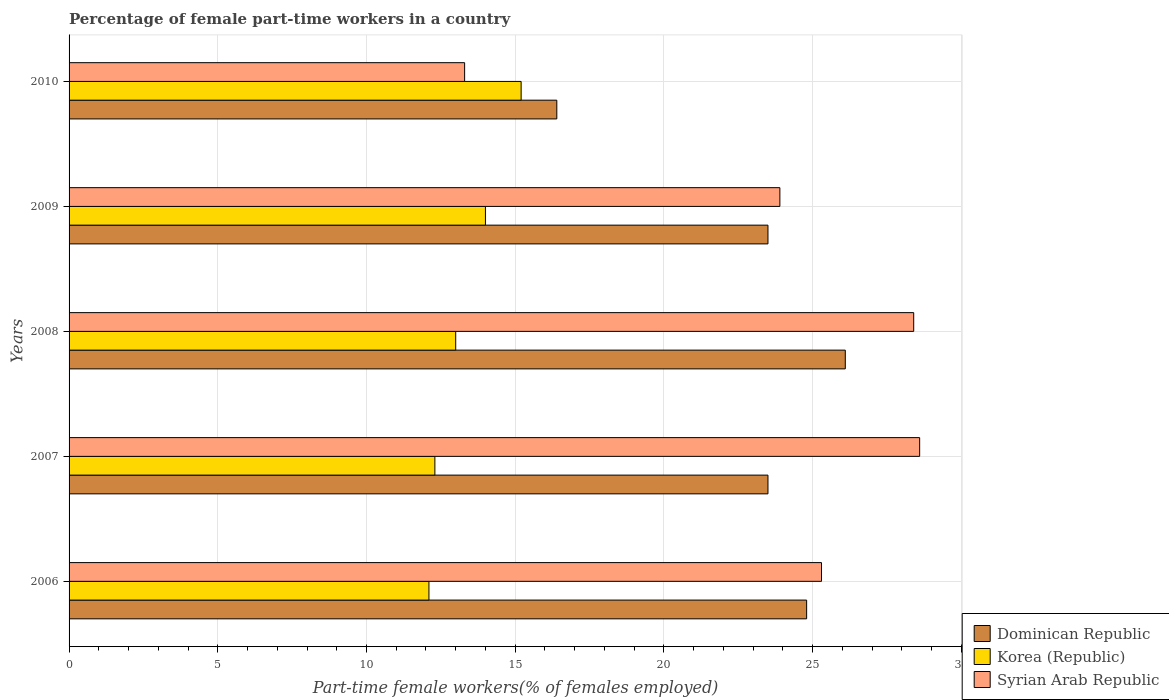How many groups of bars are there?
Your answer should be compact. 5. How many bars are there on the 1st tick from the top?
Offer a very short reply. 3. In how many cases, is the number of bars for a given year not equal to the number of legend labels?
Keep it short and to the point. 0. What is the percentage of female part-time workers in Korea (Republic) in 2007?
Make the answer very short. 12.3. Across all years, what is the maximum percentage of female part-time workers in Syrian Arab Republic?
Offer a very short reply. 28.6. Across all years, what is the minimum percentage of female part-time workers in Syrian Arab Republic?
Your answer should be compact. 13.3. In which year was the percentage of female part-time workers in Dominican Republic maximum?
Provide a succinct answer. 2008. What is the total percentage of female part-time workers in Dominican Republic in the graph?
Keep it short and to the point. 114.3. What is the difference between the percentage of female part-time workers in Syrian Arab Republic in 2007 and that in 2009?
Offer a terse response. 4.7. What is the difference between the percentage of female part-time workers in Dominican Republic in 2009 and the percentage of female part-time workers in Syrian Arab Republic in 2008?
Your answer should be compact. -4.9. What is the average percentage of female part-time workers in Korea (Republic) per year?
Offer a terse response. 13.32. In the year 2006, what is the difference between the percentage of female part-time workers in Syrian Arab Republic and percentage of female part-time workers in Korea (Republic)?
Give a very brief answer. 13.2. What is the ratio of the percentage of female part-time workers in Korea (Republic) in 2007 to that in 2009?
Your response must be concise. 0.88. Is the percentage of female part-time workers in Syrian Arab Republic in 2006 less than that in 2010?
Provide a short and direct response. No. What is the difference between the highest and the second highest percentage of female part-time workers in Syrian Arab Republic?
Keep it short and to the point. 0.2. What is the difference between the highest and the lowest percentage of female part-time workers in Korea (Republic)?
Make the answer very short. 3.1. What does the 3rd bar from the top in 2006 represents?
Ensure brevity in your answer.  Dominican Republic. What does the 2nd bar from the bottom in 2009 represents?
Keep it short and to the point. Korea (Republic). Is it the case that in every year, the sum of the percentage of female part-time workers in Korea (Republic) and percentage of female part-time workers in Syrian Arab Republic is greater than the percentage of female part-time workers in Dominican Republic?
Provide a short and direct response. Yes. How many bars are there?
Your response must be concise. 15. Are all the bars in the graph horizontal?
Your answer should be compact. Yes. What is the difference between two consecutive major ticks on the X-axis?
Give a very brief answer. 5. Are the values on the major ticks of X-axis written in scientific E-notation?
Keep it short and to the point. No. Does the graph contain any zero values?
Give a very brief answer. No. Where does the legend appear in the graph?
Your answer should be very brief. Bottom right. What is the title of the graph?
Offer a terse response. Percentage of female part-time workers in a country. What is the label or title of the X-axis?
Make the answer very short. Part-time female workers(% of females employed). What is the label or title of the Y-axis?
Your response must be concise. Years. What is the Part-time female workers(% of females employed) of Dominican Republic in 2006?
Provide a succinct answer. 24.8. What is the Part-time female workers(% of females employed) in Korea (Republic) in 2006?
Your answer should be very brief. 12.1. What is the Part-time female workers(% of females employed) of Syrian Arab Republic in 2006?
Offer a very short reply. 25.3. What is the Part-time female workers(% of females employed) of Korea (Republic) in 2007?
Your answer should be very brief. 12.3. What is the Part-time female workers(% of females employed) of Syrian Arab Republic in 2007?
Make the answer very short. 28.6. What is the Part-time female workers(% of females employed) of Dominican Republic in 2008?
Offer a terse response. 26.1. What is the Part-time female workers(% of females employed) in Korea (Republic) in 2008?
Your answer should be very brief. 13. What is the Part-time female workers(% of females employed) in Syrian Arab Republic in 2008?
Give a very brief answer. 28.4. What is the Part-time female workers(% of females employed) in Dominican Republic in 2009?
Your answer should be very brief. 23.5. What is the Part-time female workers(% of females employed) of Syrian Arab Republic in 2009?
Your answer should be compact. 23.9. What is the Part-time female workers(% of females employed) of Dominican Republic in 2010?
Your response must be concise. 16.4. What is the Part-time female workers(% of females employed) in Korea (Republic) in 2010?
Provide a short and direct response. 15.2. What is the Part-time female workers(% of females employed) in Syrian Arab Republic in 2010?
Your answer should be very brief. 13.3. Across all years, what is the maximum Part-time female workers(% of females employed) in Dominican Republic?
Provide a short and direct response. 26.1. Across all years, what is the maximum Part-time female workers(% of females employed) in Korea (Republic)?
Offer a terse response. 15.2. Across all years, what is the maximum Part-time female workers(% of females employed) of Syrian Arab Republic?
Keep it short and to the point. 28.6. Across all years, what is the minimum Part-time female workers(% of females employed) in Dominican Republic?
Your response must be concise. 16.4. Across all years, what is the minimum Part-time female workers(% of females employed) of Korea (Republic)?
Provide a succinct answer. 12.1. Across all years, what is the minimum Part-time female workers(% of females employed) in Syrian Arab Republic?
Offer a very short reply. 13.3. What is the total Part-time female workers(% of females employed) in Dominican Republic in the graph?
Ensure brevity in your answer.  114.3. What is the total Part-time female workers(% of females employed) of Korea (Republic) in the graph?
Offer a terse response. 66.6. What is the total Part-time female workers(% of females employed) of Syrian Arab Republic in the graph?
Your answer should be very brief. 119.5. What is the difference between the Part-time female workers(% of females employed) in Dominican Republic in 2006 and that in 2007?
Your answer should be very brief. 1.3. What is the difference between the Part-time female workers(% of females employed) of Korea (Republic) in 2006 and that in 2007?
Your answer should be compact. -0.2. What is the difference between the Part-time female workers(% of females employed) of Syrian Arab Republic in 2006 and that in 2007?
Provide a succinct answer. -3.3. What is the difference between the Part-time female workers(% of females employed) of Korea (Republic) in 2006 and that in 2008?
Give a very brief answer. -0.9. What is the difference between the Part-time female workers(% of females employed) in Korea (Republic) in 2006 and that in 2009?
Ensure brevity in your answer.  -1.9. What is the difference between the Part-time female workers(% of females employed) of Syrian Arab Republic in 2006 and that in 2009?
Your answer should be very brief. 1.4. What is the difference between the Part-time female workers(% of females employed) of Dominican Republic in 2007 and that in 2008?
Your response must be concise. -2.6. What is the difference between the Part-time female workers(% of females employed) in Korea (Republic) in 2007 and that in 2008?
Provide a succinct answer. -0.7. What is the difference between the Part-time female workers(% of females employed) of Korea (Republic) in 2007 and that in 2009?
Keep it short and to the point. -1.7. What is the difference between the Part-time female workers(% of females employed) of Syrian Arab Republic in 2007 and that in 2009?
Provide a succinct answer. 4.7. What is the difference between the Part-time female workers(% of females employed) of Dominican Republic in 2007 and that in 2010?
Offer a very short reply. 7.1. What is the difference between the Part-time female workers(% of females employed) in Korea (Republic) in 2007 and that in 2010?
Provide a short and direct response. -2.9. What is the difference between the Part-time female workers(% of females employed) of Dominican Republic in 2008 and that in 2009?
Provide a succinct answer. 2.6. What is the difference between the Part-time female workers(% of females employed) in Dominican Republic in 2009 and that in 2010?
Provide a short and direct response. 7.1. What is the difference between the Part-time female workers(% of females employed) in Syrian Arab Republic in 2009 and that in 2010?
Ensure brevity in your answer.  10.6. What is the difference between the Part-time female workers(% of females employed) of Korea (Republic) in 2006 and the Part-time female workers(% of females employed) of Syrian Arab Republic in 2007?
Your response must be concise. -16.5. What is the difference between the Part-time female workers(% of females employed) of Dominican Republic in 2006 and the Part-time female workers(% of females employed) of Korea (Republic) in 2008?
Offer a terse response. 11.8. What is the difference between the Part-time female workers(% of females employed) of Korea (Republic) in 2006 and the Part-time female workers(% of females employed) of Syrian Arab Republic in 2008?
Ensure brevity in your answer.  -16.3. What is the difference between the Part-time female workers(% of females employed) in Korea (Republic) in 2006 and the Part-time female workers(% of females employed) in Syrian Arab Republic in 2010?
Provide a succinct answer. -1.2. What is the difference between the Part-time female workers(% of females employed) in Dominican Republic in 2007 and the Part-time female workers(% of females employed) in Korea (Republic) in 2008?
Offer a terse response. 10.5. What is the difference between the Part-time female workers(% of females employed) of Korea (Republic) in 2007 and the Part-time female workers(% of females employed) of Syrian Arab Republic in 2008?
Your response must be concise. -16.1. What is the difference between the Part-time female workers(% of females employed) of Dominican Republic in 2007 and the Part-time female workers(% of females employed) of Syrian Arab Republic in 2009?
Provide a short and direct response. -0.4. What is the difference between the Part-time female workers(% of females employed) in Korea (Republic) in 2007 and the Part-time female workers(% of females employed) in Syrian Arab Republic in 2009?
Make the answer very short. -11.6. What is the difference between the Part-time female workers(% of females employed) in Dominican Republic in 2007 and the Part-time female workers(% of females employed) in Korea (Republic) in 2010?
Your answer should be compact. 8.3. What is the difference between the Part-time female workers(% of females employed) of Dominican Republic in 2007 and the Part-time female workers(% of females employed) of Syrian Arab Republic in 2010?
Make the answer very short. 10.2. What is the difference between the Part-time female workers(% of females employed) in Dominican Republic in 2008 and the Part-time female workers(% of females employed) in Syrian Arab Republic in 2009?
Ensure brevity in your answer.  2.2. What is the difference between the Part-time female workers(% of females employed) of Korea (Republic) in 2008 and the Part-time female workers(% of females employed) of Syrian Arab Republic in 2010?
Offer a very short reply. -0.3. What is the difference between the Part-time female workers(% of females employed) of Dominican Republic in 2009 and the Part-time female workers(% of females employed) of Korea (Republic) in 2010?
Offer a very short reply. 8.3. What is the difference between the Part-time female workers(% of females employed) of Dominican Republic in 2009 and the Part-time female workers(% of females employed) of Syrian Arab Republic in 2010?
Offer a terse response. 10.2. What is the average Part-time female workers(% of females employed) of Dominican Republic per year?
Keep it short and to the point. 22.86. What is the average Part-time female workers(% of females employed) of Korea (Republic) per year?
Give a very brief answer. 13.32. What is the average Part-time female workers(% of females employed) in Syrian Arab Republic per year?
Make the answer very short. 23.9. In the year 2006, what is the difference between the Part-time female workers(% of females employed) in Dominican Republic and Part-time female workers(% of females employed) in Korea (Republic)?
Your response must be concise. 12.7. In the year 2007, what is the difference between the Part-time female workers(% of females employed) of Dominican Republic and Part-time female workers(% of females employed) of Korea (Republic)?
Your response must be concise. 11.2. In the year 2007, what is the difference between the Part-time female workers(% of females employed) of Korea (Republic) and Part-time female workers(% of females employed) of Syrian Arab Republic?
Your response must be concise. -16.3. In the year 2008, what is the difference between the Part-time female workers(% of females employed) in Dominican Republic and Part-time female workers(% of females employed) in Korea (Republic)?
Keep it short and to the point. 13.1. In the year 2008, what is the difference between the Part-time female workers(% of females employed) in Korea (Republic) and Part-time female workers(% of females employed) in Syrian Arab Republic?
Keep it short and to the point. -15.4. In the year 2009, what is the difference between the Part-time female workers(% of females employed) in Dominican Republic and Part-time female workers(% of females employed) in Korea (Republic)?
Your answer should be compact. 9.5. In the year 2010, what is the difference between the Part-time female workers(% of females employed) of Dominican Republic and Part-time female workers(% of females employed) of Korea (Republic)?
Make the answer very short. 1.2. In the year 2010, what is the difference between the Part-time female workers(% of females employed) in Dominican Republic and Part-time female workers(% of females employed) in Syrian Arab Republic?
Your answer should be compact. 3.1. In the year 2010, what is the difference between the Part-time female workers(% of females employed) in Korea (Republic) and Part-time female workers(% of females employed) in Syrian Arab Republic?
Give a very brief answer. 1.9. What is the ratio of the Part-time female workers(% of females employed) of Dominican Republic in 2006 to that in 2007?
Offer a very short reply. 1.06. What is the ratio of the Part-time female workers(% of females employed) in Korea (Republic) in 2006 to that in 2007?
Give a very brief answer. 0.98. What is the ratio of the Part-time female workers(% of females employed) of Syrian Arab Republic in 2006 to that in 2007?
Your answer should be very brief. 0.88. What is the ratio of the Part-time female workers(% of females employed) of Dominican Republic in 2006 to that in 2008?
Ensure brevity in your answer.  0.95. What is the ratio of the Part-time female workers(% of females employed) of Korea (Republic) in 2006 to that in 2008?
Your answer should be very brief. 0.93. What is the ratio of the Part-time female workers(% of females employed) of Syrian Arab Republic in 2006 to that in 2008?
Your answer should be compact. 0.89. What is the ratio of the Part-time female workers(% of females employed) in Dominican Republic in 2006 to that in 2009?
Offer a terse response. 1.06. What is the ratio of the Part-time female workers(% of females employed) of Korea (Republic) in 2006 to that in 2009?
Offer a terse response. 0.86. What is the ratio of the Part-time female workers(% of females employed) of Syrian Arab Republic in 2006 to that in 2009?
Provide a succinct answer. 1.06. What is the ratio of the Part-time female workers(% of females employed) in Dominican Republic in 2006 to that in 2010?
Ensure brevity in your answer.  1.51. What is the ratio of the Part-time female workers(% of females employed) of Korea (Republic) in 2006 to that in 2010?
Offer a very short reply. 0.8. What is the ratio of the Part-time female workers(% of females employed) of Syrian Arab Republic in 2006 to that in 2010?
Provide a succinct answer. 1.9. What is the ratio of the Part-time female workers(% of females employed) in Dominican Republic in 2007 to that in 2008?
Your response must be concise. 0.9. What is the ratio of the Part-time female workers(% of females employed) of Korea (Republic) in 2007 to that in 2008?
Your response must be concise. 0.95. What is the ratio of the Part-time female workers(% of females employed) of Dominican Republic in 2007 to that in 2009?
Your answer should be compact. 1. What is the ratio of the Part-time female workers(% of females employed) of Korea (Republic) in 2007 to that in 2009?
Your answer should be compact. 0.88. What is the ratio of the Part-time female workers(% of females employed) in Syrian Arab Republic in 2007 to that in 2009?
Your answer should be compact. 1.2. What is the ratio of the Part-time female workers(% of females employed) of Dominican Republic in 2007 to that in 2010?
Your answer should be compact. 1.43. What is the ratio of the Part-time female workers(% of females employed) in Korea (Republic) in 2007 to that in 2010?
Your answer should be very brief. 0.81. What is the ratio of the Part-time female workers(% of females employed) of Syrian Arab Republic in 2007 to that in 2010?
Offer a terse response. 2.15. What is the ratio of the Part-time female workers(% of females employed) in Dominican Republic in 2008 to that in 2009?
Your response must be concise. 1.11. What is the ratio of the Part-time female workers(% of females employed) of Korea (Republic) in 2008 to that in 2009?
Your answer should be very brief. 0.93. What is the ratio of the Part-time female workers(% of females employed) in Syrian Arab Republic in 2008 to that in 2009?
Your answer should be very brief. 1.19. What is the ratio of the Part-time female workers(% of females employed) in Dominican Republic in 2008 to that in 2010?
Keep it short and to the point. 1.59. What is the ratio of the Part-time female workers(% of females employed) in Korea (Republic) in 2008 to that in 2010?
Provide a short and direct response. 0.86. What is the ratio of the Part-time female workers(% of females employed) of Syrian Arab Republic in 2008 to that in 2010?
Your answer should be compact. 2.14. What is the ratio of the Part-time female workers(% of females employed) of Dominican Republic in 2009 to that in 2010?
Offer a very short reply. 1.43. What is the ratio of the Part-time female workers(% of females employed) in Korea (Republic) in 2009 to that in 2010?
Your answer should be very brief. 0.92. What is the ratio of the Part-time female workers(% of females employed) in Syrian Arab Republic in 2009 to that in 2010?
Provide a succinct answer. 1.8. What is the difference between the highest and the lowest Part-time female workers(% of females employed) of Dominican Republic?
Provide a short and direct response. 9.7. What is the difference between the highest and the lowest Part-time female workers(% of females employed) of Korea (Republic)?
Give a very brief answer. 3.1. 